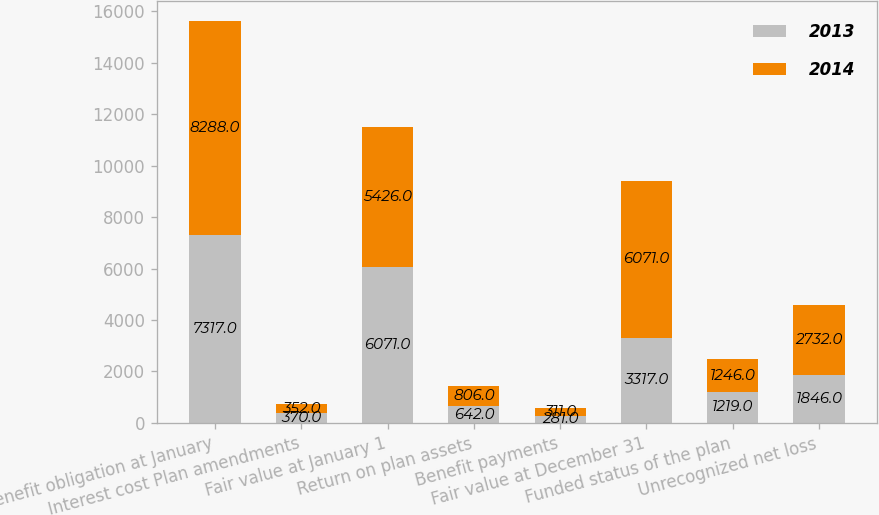<chart> <loc_0><loc_0><loc_500><loc_500><stacked_bar_chart><ecel><fcel>Benefit obligation at January<fcel>Interest cost Plan amendments<fcel>Fair value at January 1<fcel>Return on plan assets<fcel>Benefit payments<fcel>Fair value at December 31<fcel>Funded status of the plan<fcel>Unrecognized net loss<nl><fcel>2013<fcel>7317<fcel>370<fcel>6071<fcel>642<fcel>281<fcel>3317<fcel>1219<fcel>1846<nl><fcel>2014<fcel>8288<fcel>352<fcel>5426<fcel>806<fcel>311<fcel>6071<fcel>1246<fcel>2732<nl></chart> 